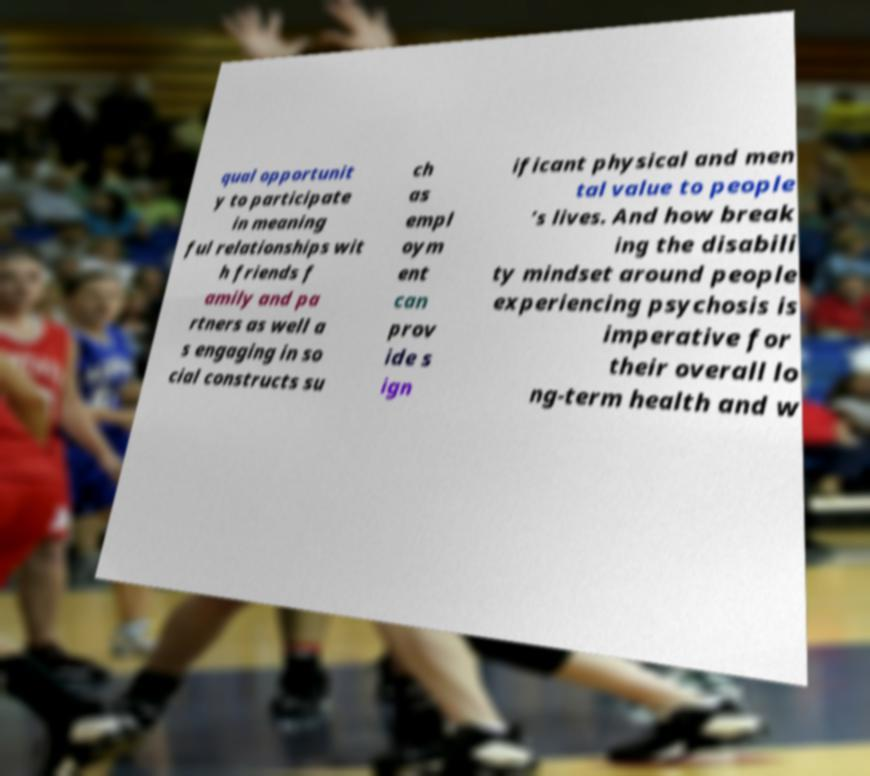Could you assist in decoding the text presented in this image and type it out clearly? qual opportunit y to participate in meaning ful relationships wit h friends f amily and pa rtners as well a s engaging in so cial constructs su ch as empl oym ent can prov ide s ign ificant physical and men tal value to people ’s lives. And how break ing the disabili ty mindset around people experiencing psychosis is imperative for their overall lo ng-term health and w 